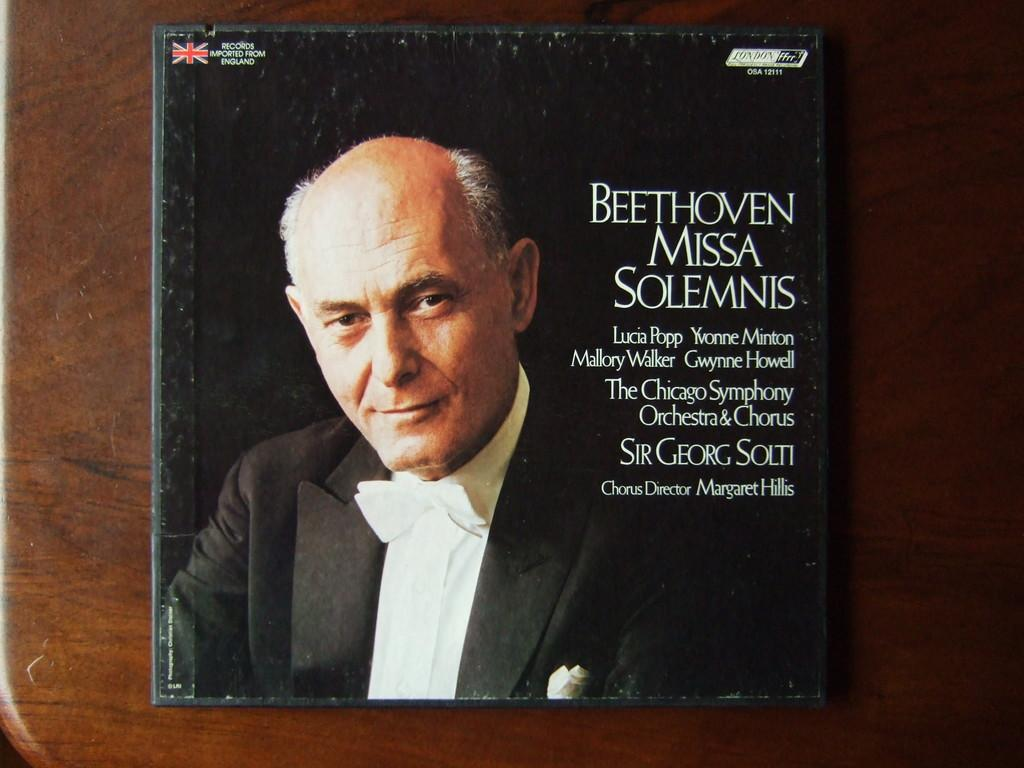<image>
Present a compact description of the photo's key features. A Beethoven music CD features Sir Georg Solti. 